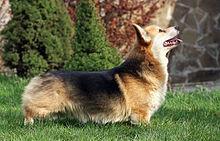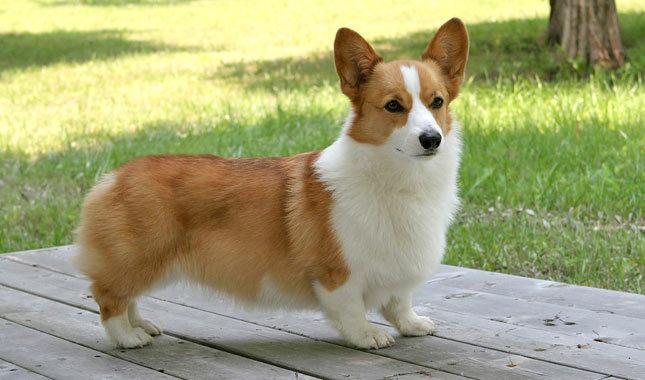The first image is the image on the left, the second image is the image on the right. Evaluate the accuracy of this statement regarding the images: "There are two dogs facing each other.". Is it true? Answer yes or no. No. The first image is the image on the left, the second image is the image on the right. Examine the images to the left and right. Is the description "The bodies of the dogs in the two images turn toward each other." accurate? Answer yes or no. No. The first image is the image on the left, the second image is the image on the right. For the images shown, is this caption "The dogs in the images are standing with bodies turned in opposite directions." true? Answer yes or no. No. 